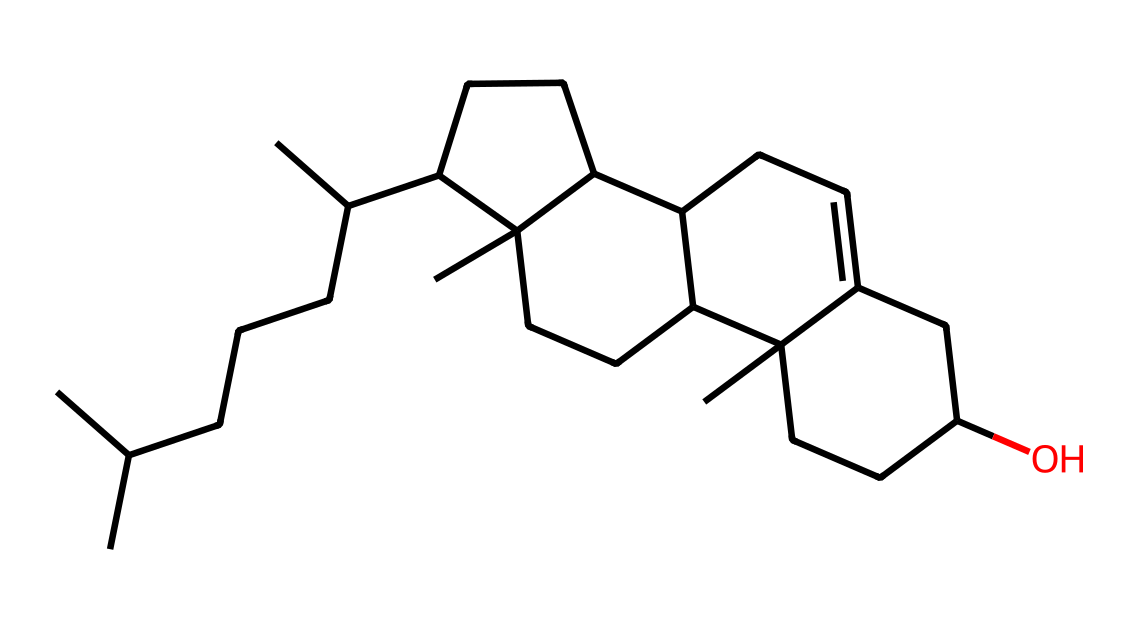how many carbon atoms are in this chemical structure? By counting the carbon atoms in the provided SMILES, we recognize segments indicating carbon chains and rings. Including all parts of the structure, there are 30 carbon atoms.
Answer: 30 how many rings does this molecule have? In the structure indicated by the SMILES, there are connections that suggest cycloalkane formations. Upon examination, this molecule has 4 rings identified within the chemical structure.
Answer: 4 what type of lipid is represented by this chemical? This chemical is characterized by containing a sterol structure, known for specific functional groups and ring formations typical of cholesterol. Therefore, it represents a sterol-type lipid.
Answer: sterol does this cholesterol structure contain any functional groups? Analyzing the structure reveals the presence of hydroxyl (OH) groups indicated at specific points in the SMILES notation, confirming the existence of functional groups in the chemical.
Answer: yes what is the primary role of cholesterol in the body? Cholesterol is crucial for producing hormones and forming cell membranes, playing a key role in maintaining cellular structure and fluidity. Hence, it serves as a building block in these processes.
Answer: building block is this cholesterol derived from animal or plant sources? Cholesterol is primarily synthesized in animal cells and is not typically found in plant sources, making it an animal-derived sterol.
Answer: animal-derived 